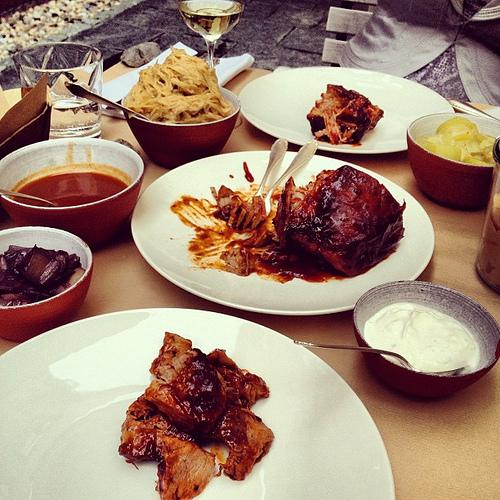Identify the primary focus of the image and provide a brief explanation. The main focus is on various dishes of food on a table, with meats covered in sauce, bowls filled with sauces, and glasses containing different drinks. In a casual way, explain the components of the image related to dining. So, there's this table set up for a meal, right? And there's a bunch of plates with some delicious-looking dishes, like BBQ pork and sweet potatoes. Plus, there are wine and water glasses, and don't forget the sauces in those cool bowls! Is there any indication of a person in the image? If so, describe briefly. Yes, a person is sitting at the table, but the focus is on the food and table setting. What type of meat is on the white plate? The meat on the white plate is likely barbecue pork covered in sauce. Explain the state of the plate with the meat covered in sauce. The plate appears messy, with sauce smeared on it and a chunk of cooked meat partially separated from the edge of the bones. Describe the table setup, including dishware and cutlery. The table is set with various bowls and plates filled with food, glasses containing wine and water, and utensils like forks and spoons, accompanied by a white napkin. What types of beverages are present in the image? The beverages include white wine in a stemmed glass, and water in a glass with cut designs. Briefly describe the colors and contents of the bowls and plates in the image. The image features a red bowl with red sauce, a ceramic bowl with creamy sauce, a gray bowl with white cream, a high mound of puree in a dark bowl, and various plates filled with meats and sauces. What are the contents of the gray bowl? The gray bowl contains white cream. In a poetic manner, describe the scene in the image. A symphony of flavors and textures unfolded upon the table, the stage set for a feast of delights, where red sauces danced with white creams, and golden wine shimmered in glasses, engaged in a tantalizing tableau of culinary artistry. Do you see a bowl of fruit in the image? The given information mentions a variety of dishes, sauces, and other details, but there is no mention of a bowl of fruit. Is there a blue bowl with hot sauce and utensil in the image? There is a red bowl with hot sauce and utensil, but there is no mention of a blue bowl in the given information. Can you find a glass of red wine on the table? There is a white wine in a stemmed glass and a glass of water mentioned, but there is no mention of a glass of red wine in the given information. Is there a green tablecloth on the table? There is a mention of a tan tablecloth but no mention of a green tablecloth in the given information. Can you locate a plate with fish on it in the image? The image mentions several instances of meat dishes, but there is no mention of a plate with fish in the given information. Are there any blue napkins on the table? There is a mention of a white napkin, but there is no mention of any blue napkins in the given information. 